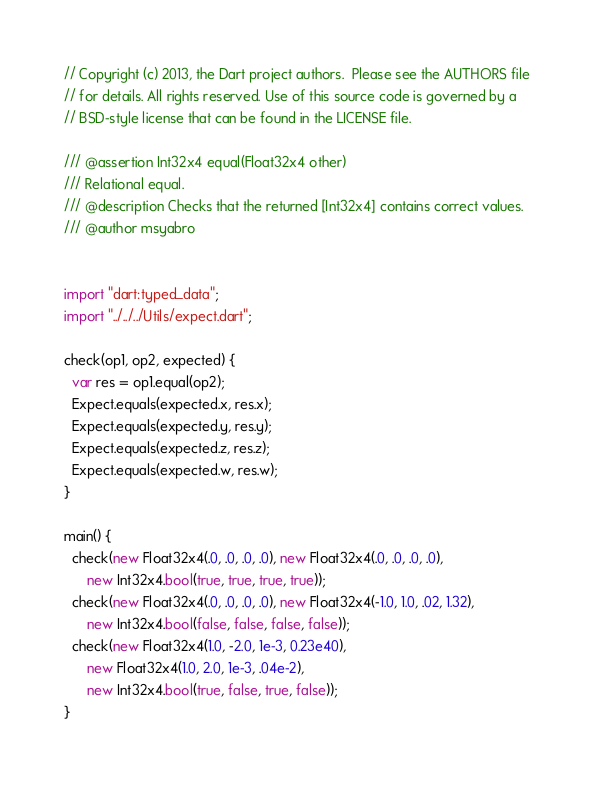<code> <loc_0><loc_0><loc_500><loc_500><_Dart_>// Copyright (c) 2013, the Dart project authors.  Please see the AUTHORS file
// for details. All rights reserved. Use of this source code is governed by a
// BSD-style license that can be found in the LICENSE file.

/// @assertion Int32x4 equal(Float32x4 other)
/// Relational equal.
/// @description Checks that the returned [Int32x4] contains correct values.
/// @author msyabro


import "dart:typed_data";
import "../../../Utils/expect.dart";

check(op1, op2, expected) {
  var res = op1.equal(op2);
  Expect.equals(expected.x, res.x);
  Expect.equals(expected.y, res.y);
  Expect.equals(expected.z, res.z);
  Expect.equals(expected.w, res.w);
}

main() {
  check(new Float32x4(.0, .0, .0, .0), new Float32x4(.0, .0, .0, .0),
      new Int32x4.bool(true, true, true, true));
  check(new Float32x4(.0, .0, .0, .0), new Float32x4(-1.0, 1.0, .02, 1.32),
      new Int32x4.bool(false, false, false, false));
  check(new Float32x4(1.0, -2.0, 1e-3, 0.23e40),
      new Float32x4(1.0, 2.0, 1e-3, .04e-2),
      new Int32x4.bool(true, false, true, false));
}
</code> 